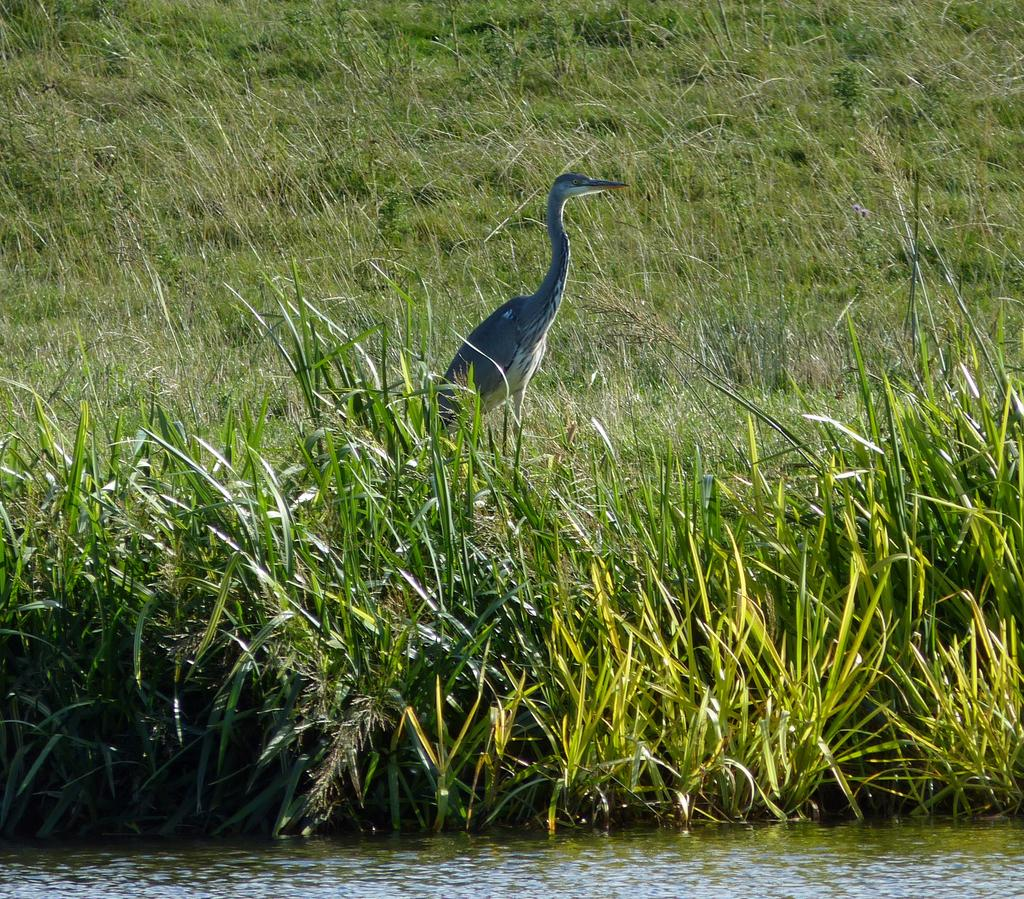What is the main subject in the center of the image? There is a crane in the center of the image. What can be seen at the bottom side of the image? There is water at the bottom side of the image. What type of landscape is visible at the top side of the image? There is grassland at the top side of the image. What date is marked on the calendar in the image? There is no calendar present in the image. What type of operation is being performed by the crane in the image? The image does not show the crane performing any operation; it is simply depicted in the center of the image. 